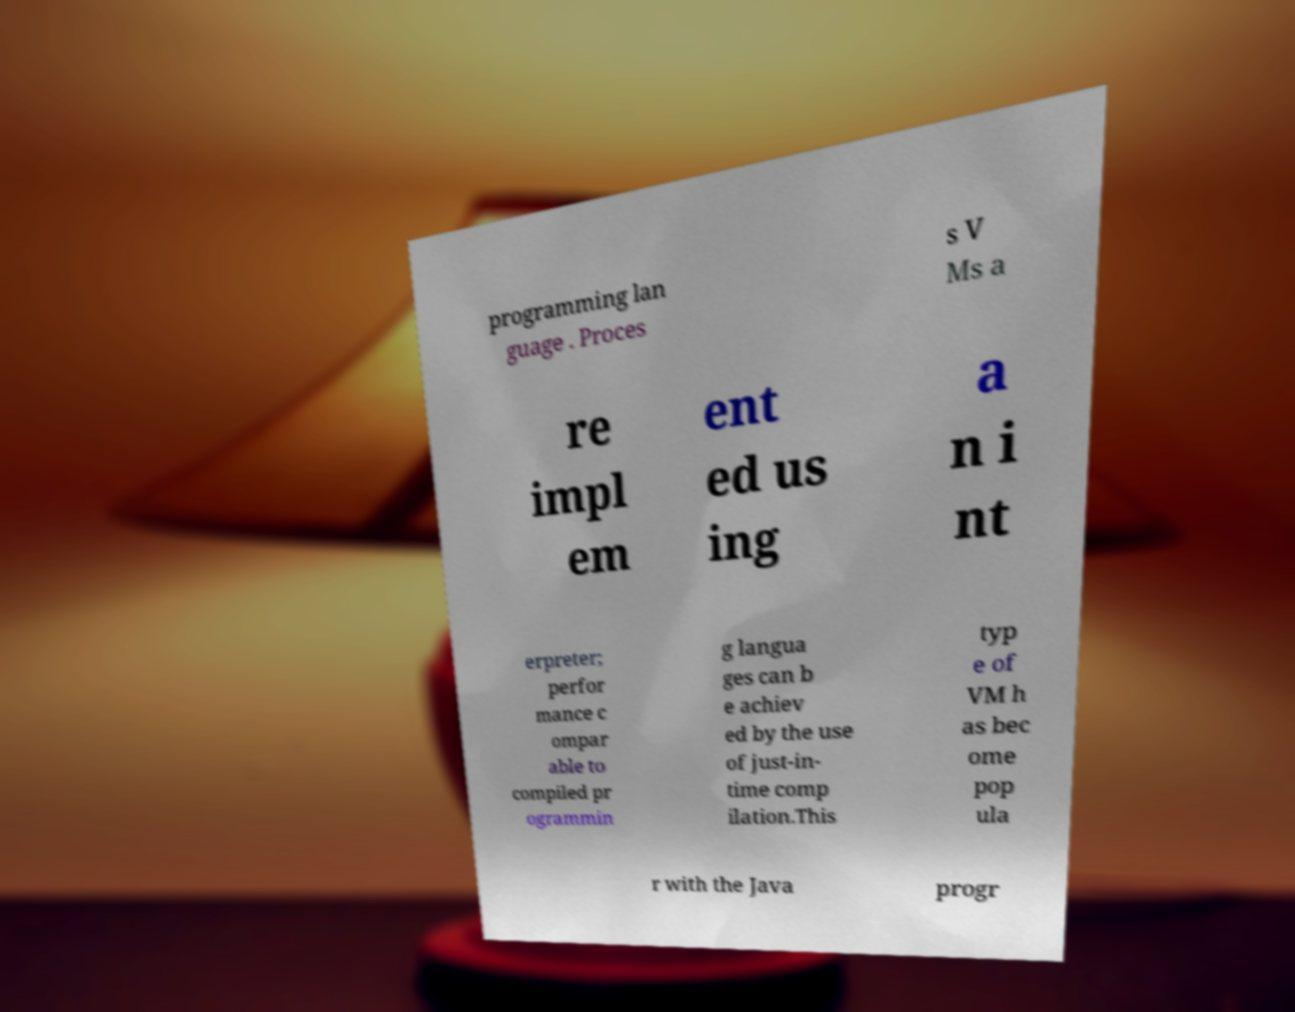Please read and relay the text visible in this image. What does it say? programming lan guage . Proces s V Ms a re impl em ent ed us ing a n i nt erpreter; perfor mance c ompar able to compiled pr ogrammin g langua ges can b e achiev ed by the use of just-in- time comp ilation.This typ e of VM h as bec ome pop ula r with the Java progr 